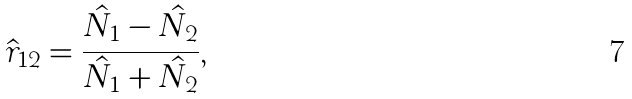<formula> <loc_0><loc_0><loc_500><loc_500>\hat { r } _ { 1 2 } = \frac { \hat { N _ { 1 } } - \hat { N _ { 2 } } } { \hat { N _ { 1 } } + \hat { N _ { 2 } } } ,</formula> 